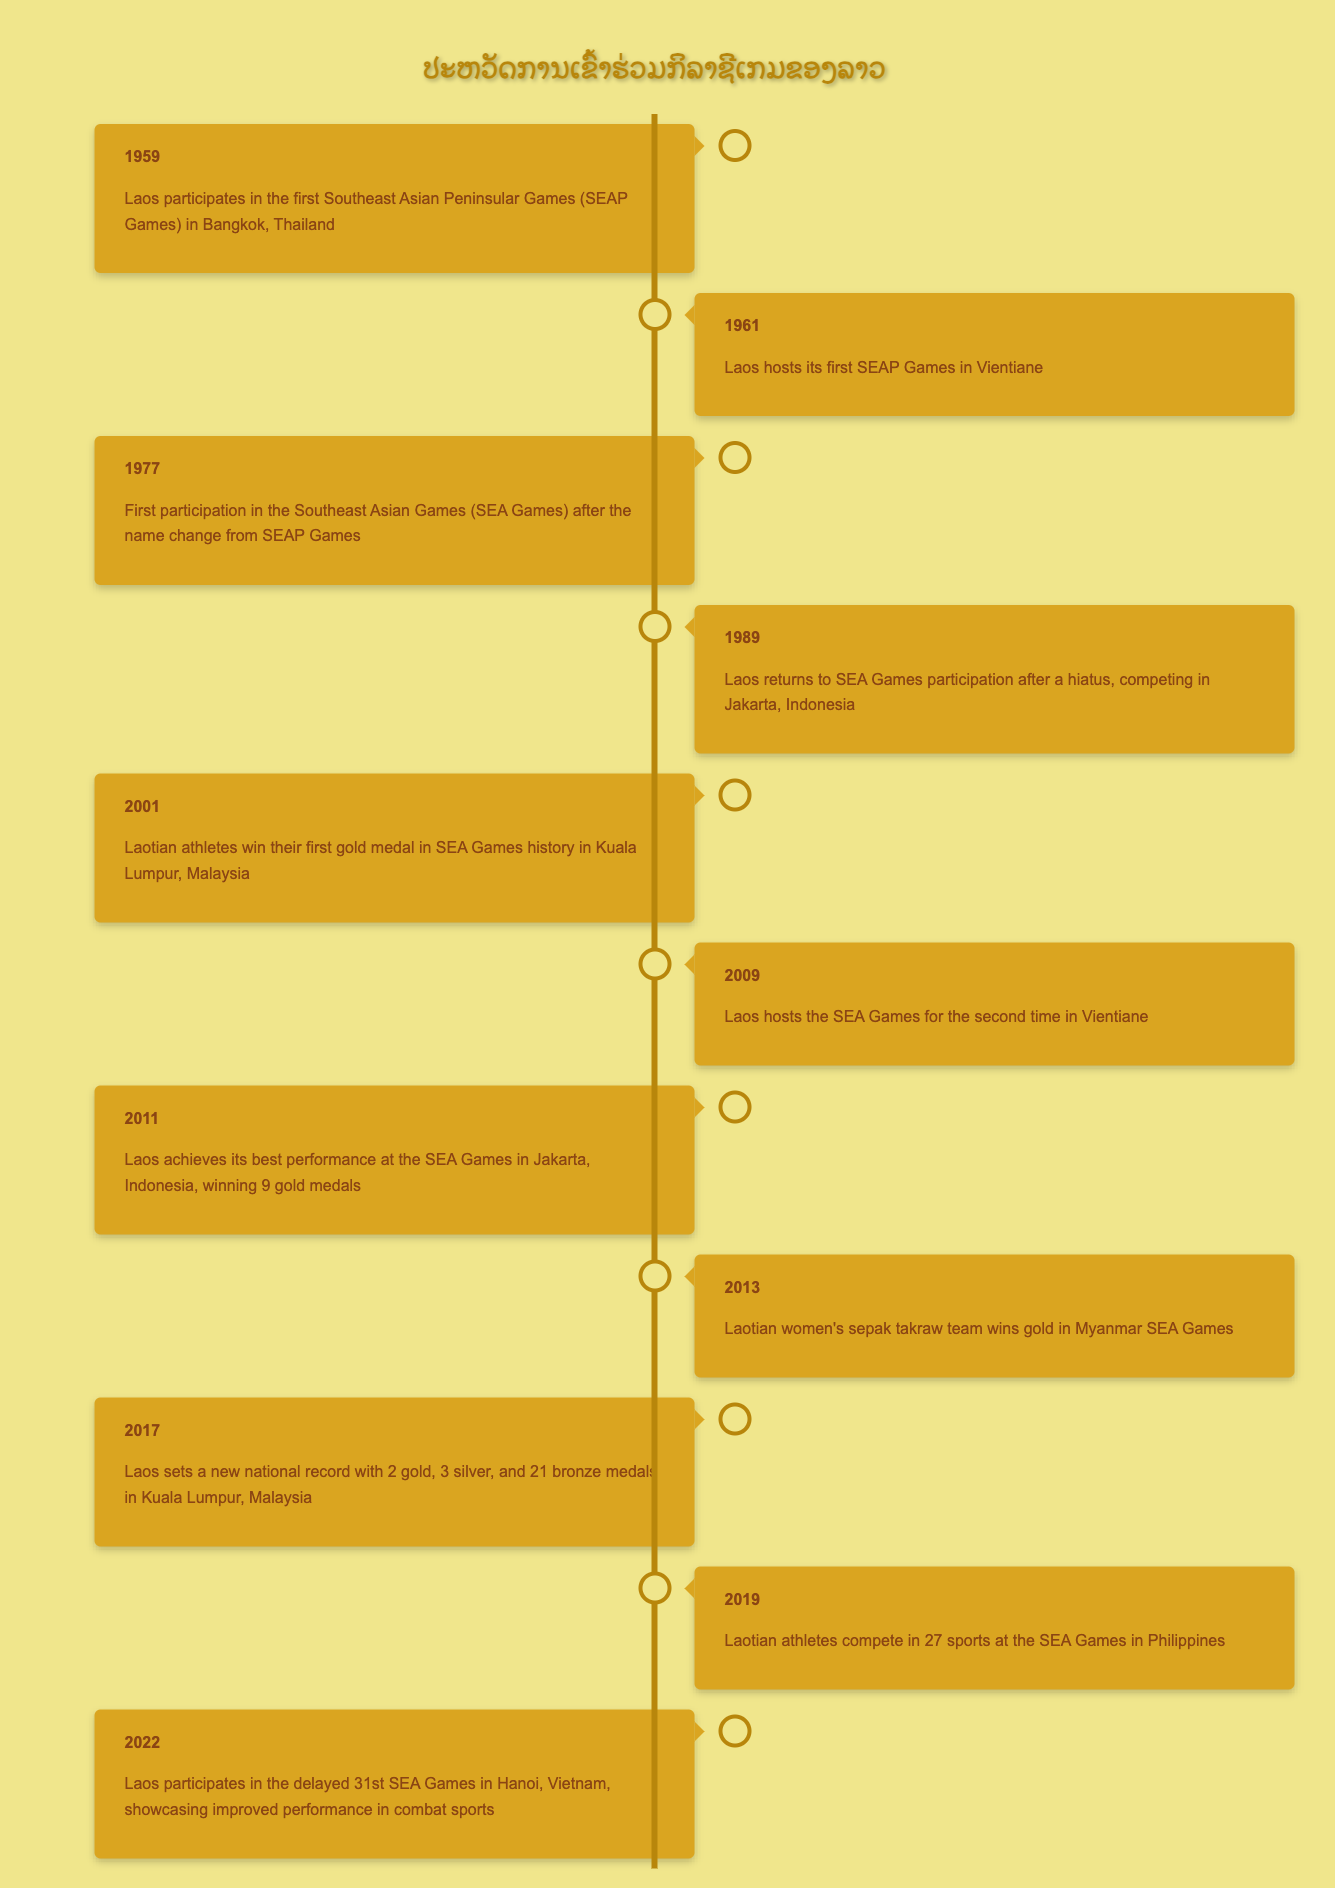What year did Laos first participate in the SEA Games? The table shows the entry for Laos' first participation in the SEA Games listed under the year 1977, indicating this was the first time after the name change from SEAP Games to SEA Games.
Answer: 1977 Which event marks the best performance of Laos in the SEA Games? According to the table, the best performance of Laos at the SEA Games is noted in 2011, where they won 9 gold medals in Jakarta, Indonesia.
Answer: 2011 How many gold medals did Laos win in 2017? The entry for 2017 states that Laos set a national record with 2 gold medals, thus the answer is based purely on this record.
Answer: 2 Has Laos hosted the SEA Games more than once? The table lists two entries for Laos hosting the SEA Games, in 1961 and again in 2009, confirming that the statement is true.
Answer: Yes What is the total number of times Laos has participated in the SEA Games from 1959 to 2022? We start counting from the year 1959 (1), then in 1977 (2), 1989 (3), 2001 (4), 2009 (5), 2011 (6), 2013 (7), 2017 (8), 2019 (9), and lastly in 2022 (10). Summing these gives a total of 10 participations.
Answer: 10 In which year did Laos win its first gold medal in SEA Games history? The table indicates that Laos won its first gold medal during the SEA Games in 2001, thus we directly reference this specific entry to provide the answer.
Answer: 2001 What types of sports did Laos compete in during the 2019 SEA Games? In 2019, the table notes that Laotian athletes competed in 27 different sports at the SEA Games in the Philippines; however, it does not specify what those sports were. Therefore, the answer reflects the number of sports competed in, not the specific types.
Answer: 27 What significant achievement did the Laotian women's sepak takraw team accomplish in 2013? The table notes that in 2013, the Laotian women's sepak takraw team won a gold medal at the SEA Games held in Myanmar. This indicates a specific notable achievement for that year in the context of Laos' participation.
Answer: Won gold How did the number of gold medals won by Laos in 2011 compare to 2017? Looking at the table, Laos won 9 gold medals in 2011 and 2 gold medals in 2017. To compare, we can see that 9 is significantly higher than 2, indicating a better performance in 2011.
Answer: 9 > 2 